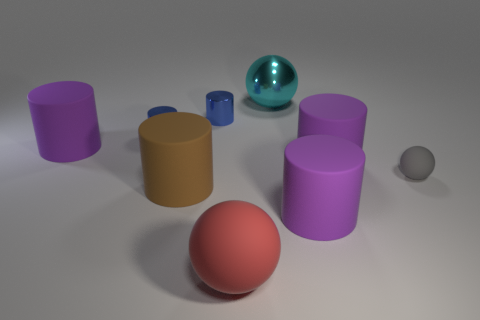Subtract all gray matte balls. How many balls are left? 2 Subtract all cyan spheres. How many spheres are left? 2 Add 1 tiny purple rubber cylinders. How many objects exist? 10 Subtract 6 cylinders. How many cylinders are left? 0 Subtract all cyan cylinders. How many yellow spheres are left? 0 Subtract all purple blocks. Subtract all gray objects. How many objects are left? 8 Add 7 cyan shiny spheres. How many cyan shiny spheres are left? 8 Add 3 gray balls. How many gray balls exist? 4 Subtract 0 yellow cylinders. How many objects are left? 9 Subtract all cylinders. How many objects are left? 3 